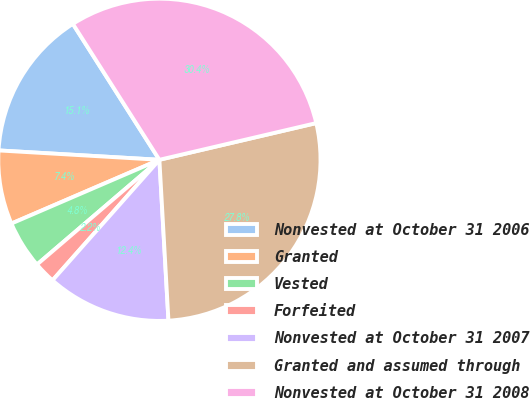<chart> <loc_0><loc_0><loc_500><loc_500><pie_chart><fcel>Nonvested at October 31 2006<fcel>Granted<fcel>Vested<fcel>Forfeited<fcel>Nonvested at October 31 2007<fcel>Granted and assumed through<fcel>Nonvested at October 31 2008<nl><fcel>15.05%<fcel>7.4%<fcel>4.79%<fcel>2.19%<fcel>12.44%<fcel>27.76%<fcel>30.36%<nl></chart> 